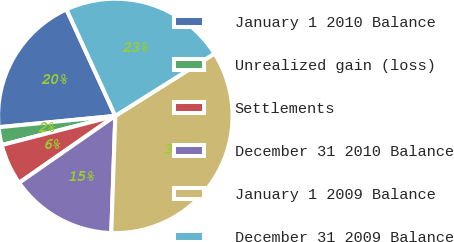<chart> <loc_0><loc_0><loc_500><loc_500><pie_chart><fcel>January 1 2010 Balance<fcel>Unrealized gain (loss)<fcel>Settlements<fcel>December 31 2010 Balance<fcel>January 1 2009 Balance<fcel>December 31 2009 Balance<nl><fcel>19.7%<fcel>2.46%<fcel>5.67%<fcel>14.78%<fcel>34.48%<fcel>22.91%<nl></chart> 